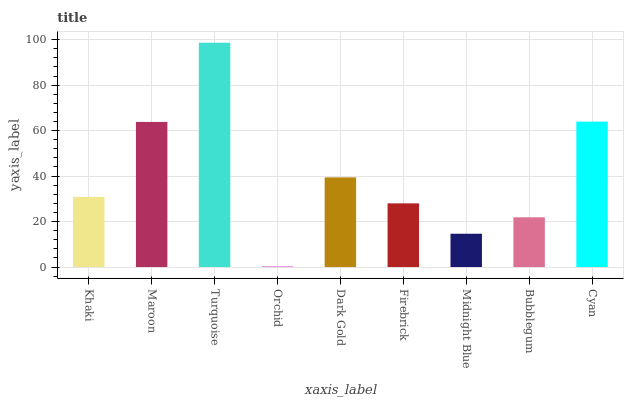Is Maroon the minimum?
Answer yes or no. No. Is Maroon the maximum?
Answer yes or no. No. Is Maroon greater than Khaki?
Answer yes or no. Yes. Is Khaki less than Maroon?
Answer yes or no. Yes. Is Khaki greater than Maroon?
Answer yes or no. No. Is Maroon less than Khaki?
Answer yes or no. No. Is Khaki the high median?
Answer yes or no. Yes. Is Khaki the low median?
Answer yes or no. Yes. Is Firebrick the high median?
Answer yes or no. No. Is Bubblegum the low median?
Answer yes or no. No. 